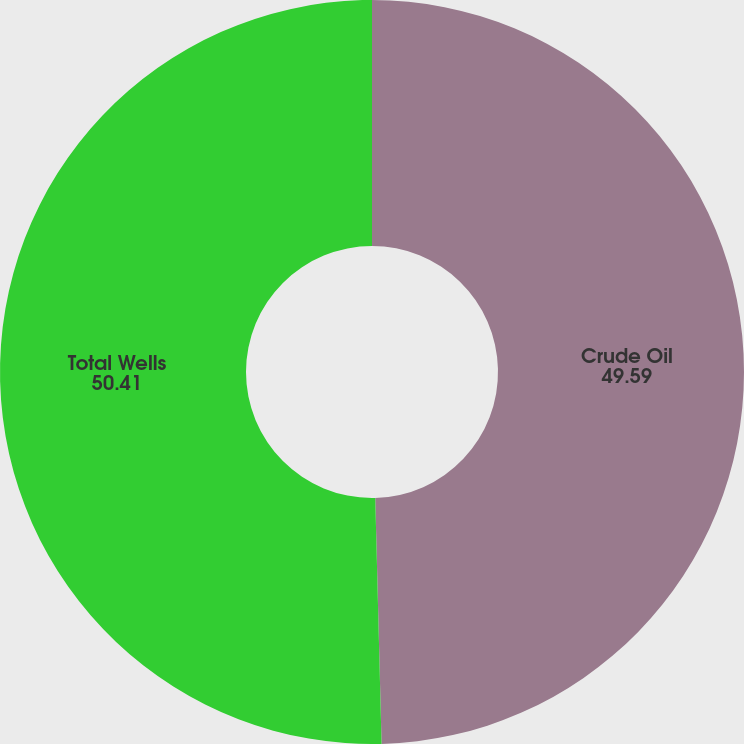Convert chart to OTSL. <chart><loc_0><loc_0><loc_500><loc_500><pie_chart><fcel>Crude Oil<fcel>Total Wells<nl><fcel>49.59%<fcel>50.41%<nl></chart> 